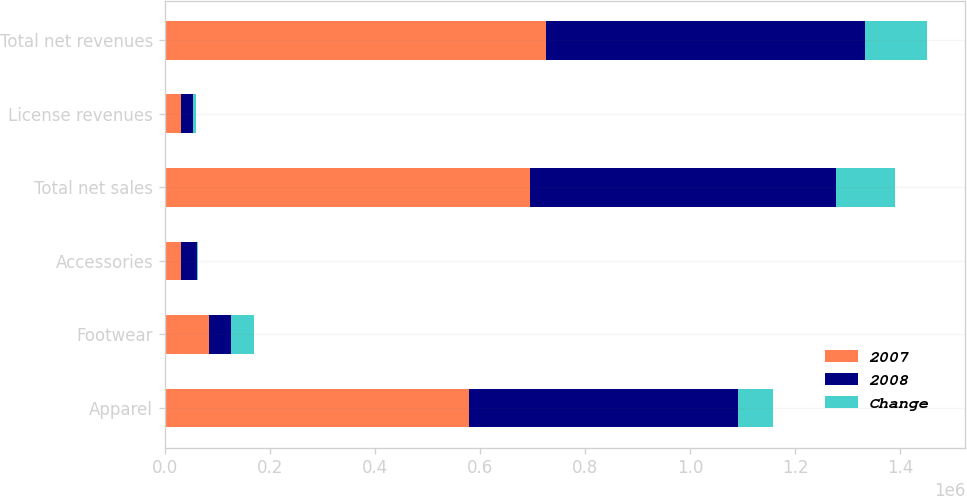<chart> <loc_0><loc_0><loc_500><loc_500><stacked_bar_chart><ecel><fcel>Apparel<fcel>Footwear<fcel>Accessories<fcel>Total net sales<fcel>License revenues<fcel>Total net revenues<nl><fcel>2007<fcel>578887<fcel>84848<fcel>31547<fcel>695282<fcel>29962<fcel>725244<nl><fcel>2008<fcel>512613<fcel>40878<fcel>29054<fcel>582545<fcel>24016<fcel>606561<nl><fcel>Change<fcel>66274<fcel>43970<fcel>2493<fcel>112737<fcel>5946<fcel>118683<nl></chart> 